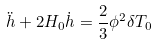<formula> <loc_0><loc_0><loc_500><loc_500>\ddot { h } + 2 H _ { 0 } \dot { h } = \frac { 2 } { 3 } { \phi } ^ { 2 } { \delta } T _ { 0 }</formula> 